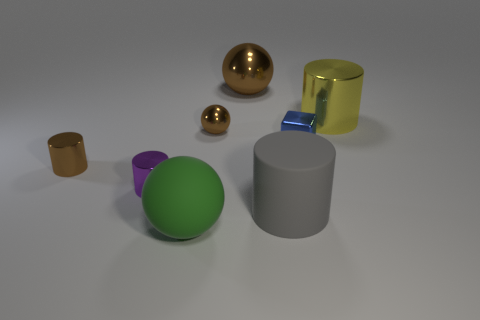Do the metallic block and the big rubber cylinder have the same color?
Your answer should be compact. No. What number of other things are the same shape as the big brown metallic thing?
Make the answer very short. 2. How many yellow objects are either metallic cubes or big metal objects?
Provide a succinct answer. 1. What is the color of the big cylinder that is the same material as the blue cube?
Ensure brevity in your answer.  Yellow. Are the big ball that is in front of the large yellow cylinder and the brown object behind the tiny brown metal ball made of the same material?
Make the answer very short. No. What size is the metal cylinder that is the same color as the big metal sphere?
Offer a terse response. Small. There is a brown thing to the left of the green object; what is its material?
Your answer should be very brief. Metal. There is a shiny thing that is behind the large yellow thing; does it have the same shape as the tiny shiny thing right of the gray matte thing?
Your answer should be compact. No. What material is the big ball that is the same color as the tiny sphere?
Offer a very short reply. Metal. Are any purple metal things visible?
Your answer should be compact. Yes. 